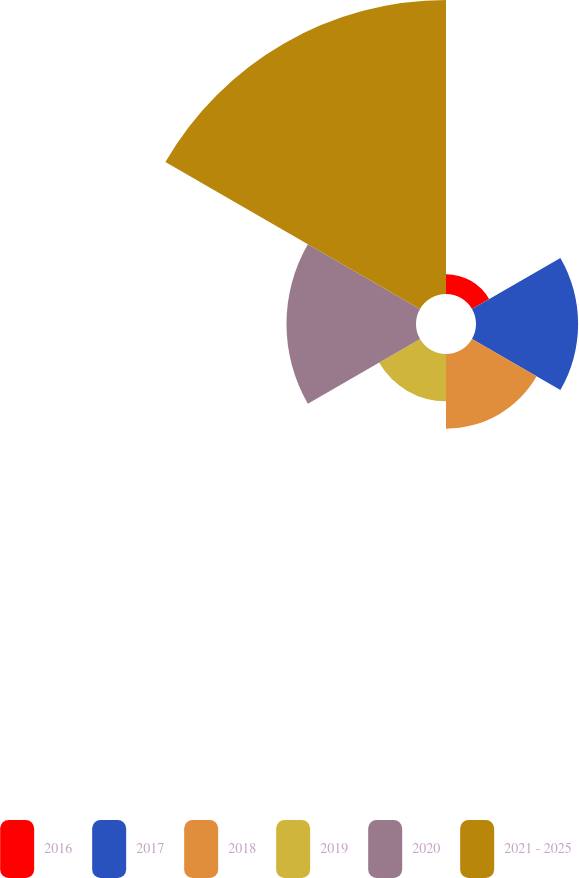<chart> <loc_0><loc_0><loc_500><loc_500><pie_chart><fcel>2016<fcel>2017<fcel>2018<fcel>2019<fcel>2020<fcel>2021 - 2025<nl><fcel>2.97%<fcel>15.3%<fcel>11.19%<fcel>7.08%<fcel>19.41%<fcel>44.06%<nl></chart> 